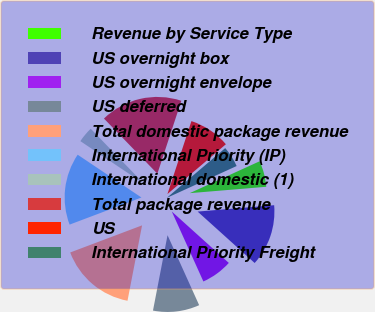Convert chart to OTSL. <chart><loc_0><loc_0><loc_500><loc_500><pie_chart><fcel>Revenue by Service Type<fcel>US overnight box<fcel>US overnight envelope<fcel>US deferred<fcel>Total domestic package revenue<fcel>International Priority (IP)<fcel>International domestic (1)<fcel>Total package revenue<fcel>US<fcel>International Priority Freight<nl><fcel>5.49%<fcel>13.0%<fcel>6.57%<fcel>9.79%<fcel>16.22%<fcel>15.15%<fcel>3.35%<fcel>17.3%<fcel>8.71%<fcel>4.42%<nl></chart> 